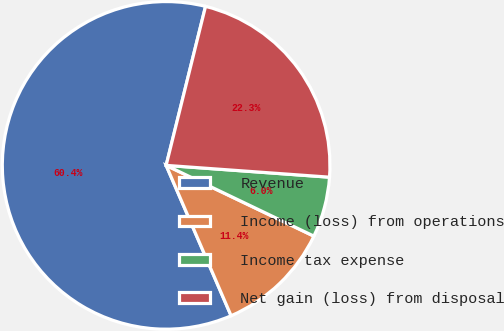Convert chart to OTSL. <chart><loc_0><loc_0><loc_500><loc_500><pie_chart><fcel>Revenue<fcel>Income (loss) from operations<fcel>Income tax expense<fcel>Net gain (loss) from disposal<nl><fcel>60.36%<fcel>11.4%<fcel>5.96%<fcel>22.28%<nl></chart> 